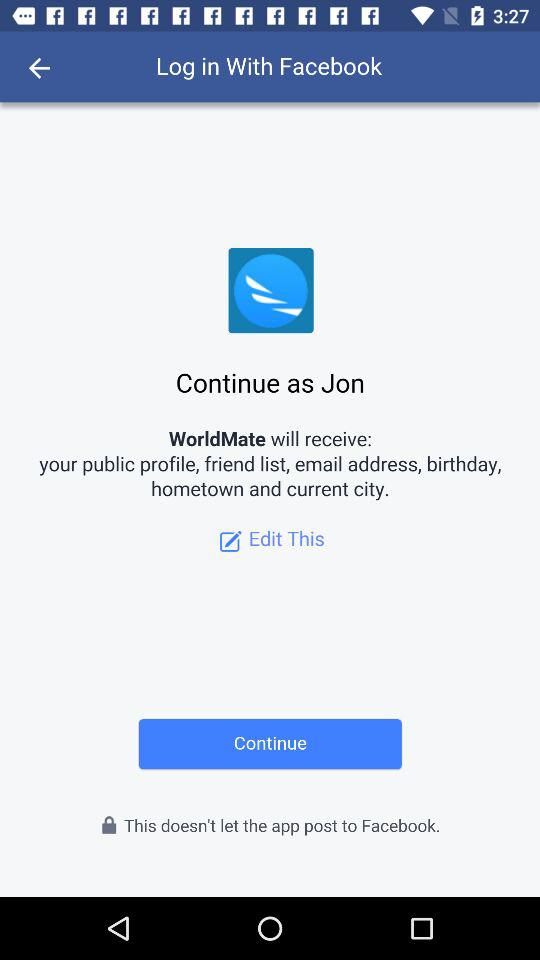What application is asking for permission? The application asking for permission is "WorldMate". 